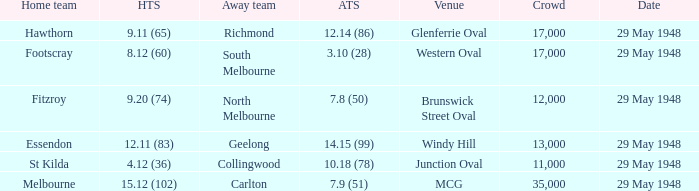In the match where north melbourne was the away team, how much did the home team score? 9.20 (74). 